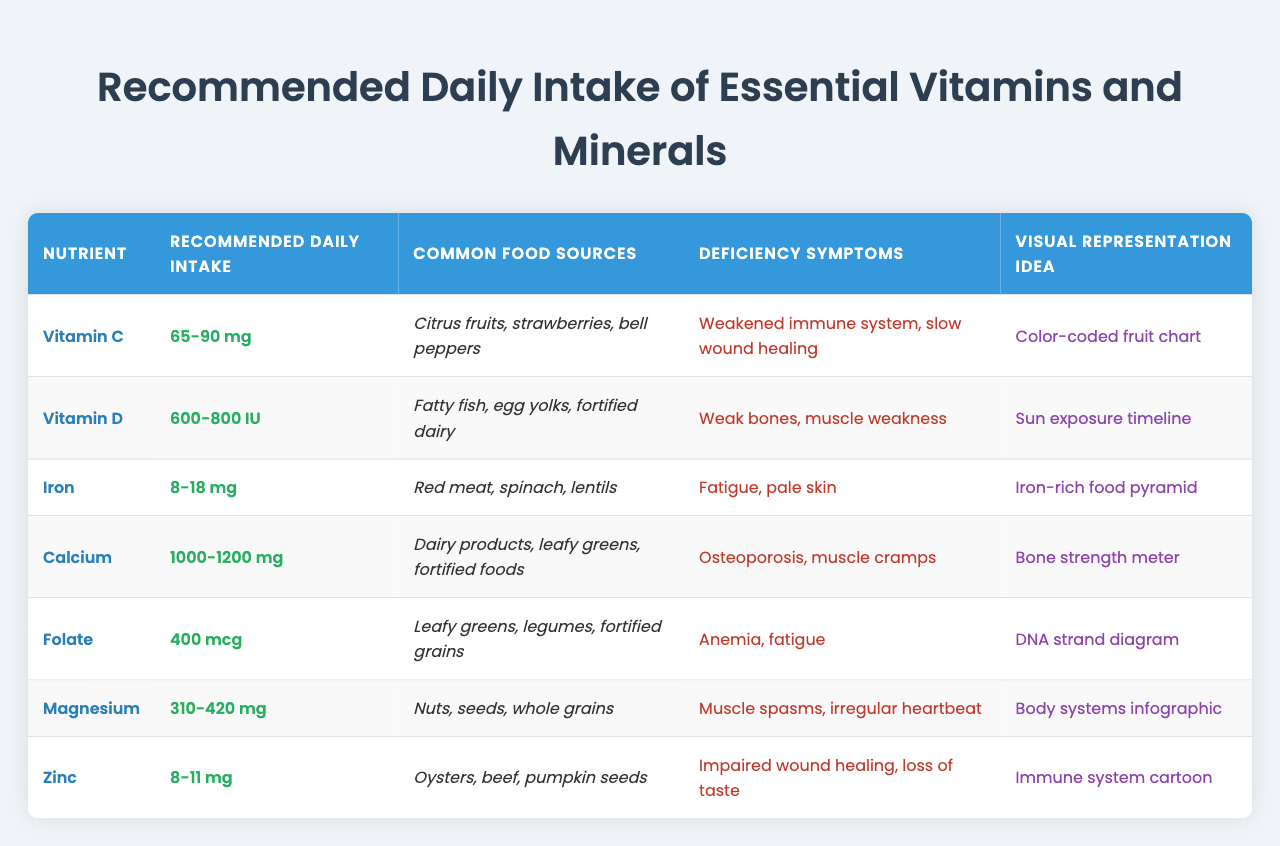What is the recommended daily intake of Vitamin C? The table lists Vitamin C under the "Nutrient" column, showing a recommended daily intake of 65-90 mg.
Answer: 65-90 mg What are common food sources of Calcium? Referring to the table, under the "Common Food Sources" for Calcium, it lists dairy products, leafy greens, and fortified foods.
Answer: Dairy products, leafy greens, and fortified foods True or False: Spinach is a common food source of Iron. The table includes Iron under "Common Food Sources" where spinach is explicitly mentioned. Therefore, the statement is true.
Answer: True What is the difference in the recommended daily intake between Iron and Zinc? Iron's recommended daily intake is 8-18 mg, and Zinc's is 8-11 mg. The difference is calculated by subtracting the upper limit of Zinc (11) from the upper limit of Iron (18), giving us 7 mg.
Answer: 7 mg Which nutrient has the highest recommended daily intake based on the table? By comparing the maximum values in the "Recommended Daily Intake" column, Calcium has a range of 1000-1200 mg, which is higher than the other nutrients.
Answer: Calcium How many vitamins and minerals have a recommended daily intake lower than 100 mg? Reviewing the table, Vitamin C (65-90 mg), Iron (8-18 mg), and Zinc (8-11 mg) have recommended intakes below 100 mg. There are three nutrients in total.
Answer: 3 What is the average recommended daily intake of Vitamin D and Folate? Vitamin D's intake is 600-800 IU (average of 700 IU), and Folate's is 400 mcg. To find the average of these two averages, convert IU to mcg using the conversion 1 IU Vitamin D = 0.025 mcg. Thus, 700 IU = 17.5 mcg. The average is (17.5 + 400) / 2 = 208.75 mcg.
Answer: 208.75 mcg Which nutrient is associated with muscle spasms according to the deficiency symptoms? Looking at the "Deficiency Symptoms" column, Magnesium corresponds to muscle spasms listed under its row.
Answer: Magnesium How can deficiencies in Vitamin D impact bone health compared to Calcium? Both Vitamin D and Calcium are important for bone health; Vitamin D deficiency leads to weak bones, while Calcium is related to the risk of osteoporosis. Thus, both are critical for maintaining bone strength, but deficiencies manifest differently.
Answer: Both are critical for bone health 